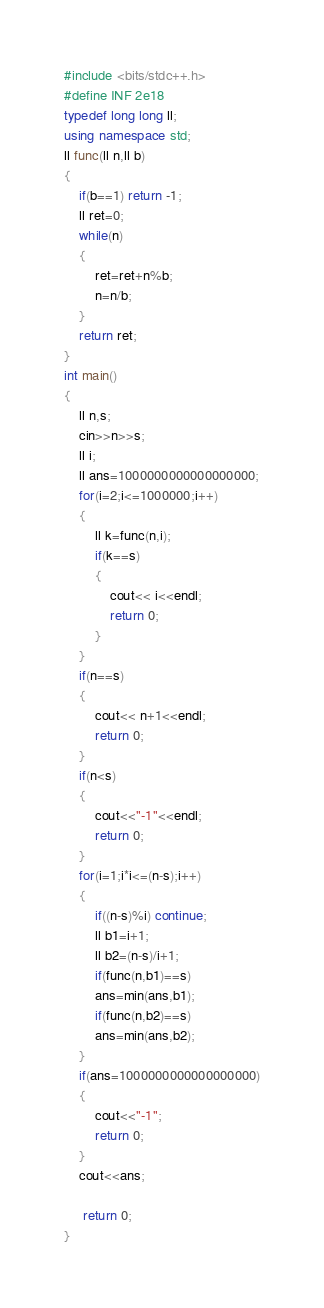Convert code to text. <code><loc_0><loc_0><loc_500><loc_500><_C++_>#include <bits/stdc++.h>
#define INF 2e18
typedef long long ll;
using namespace std;
ll func(ll n,ll b)
{
	if(b==1) return -1;
	ll ret=0;
	while(n)
	{
		ret=ret+n%b;
		n=n/b;
	}
	return ret;
}
int main()
{
    ll n,s;
    cin>>n>>s;
    ll i;
    ll ans=1000000000000000000;
    for(i=2;i<=1000000;i++)
    {
    	ll k=func(n,i);
    	if(k==s)
    	{
    		cout<< i<<endl;
    		return 0;
		}
	}
	if(n==s)
	{
		cout<< n+1<<endl;
		return 0;
	}
	if(n<s)
	{
		cout<<"-1"<<endl;
		return 0;
	}
	for(i=1;i*i<=(n-s);i++)
	{
		if((n-s)%i) continue;
		ll b1=i+1;
		ll b2=(n-s)/i+1;
		if(func(n,b1)==s)
		ans=min(ans,b1);
		if(func(n,b2)==s)
		ans=min(ans,b2);
	}
	if(ans=1000000000000000000)
	{
		cout<<"-1";
		return 0;
	}
	cout<<ans;
	
	 return 0;		
}</code> 